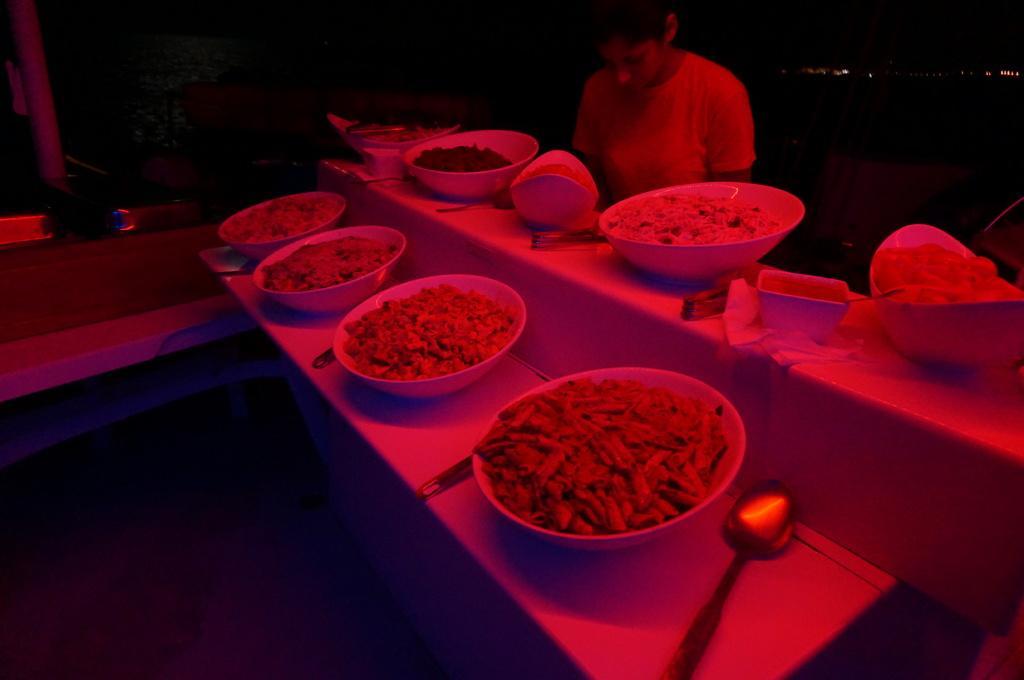Can you describe this image briefly? In this picture there is a person standing and we can see bowls, food, spoons and objects on tables. In the background of the image it is dark. 